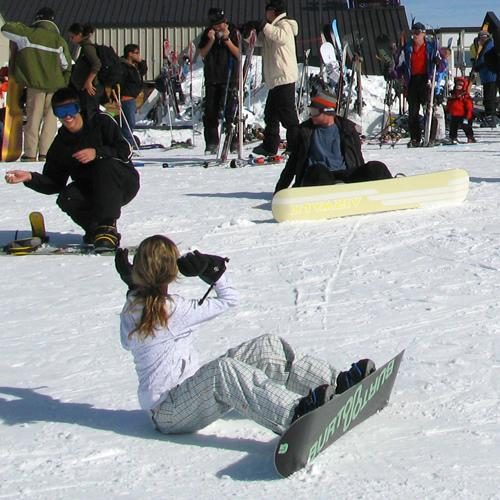What are the people sitting in the snow doing?

Choices:
A) waiting
B) sledding
C) gambling
D) skiing waiting 